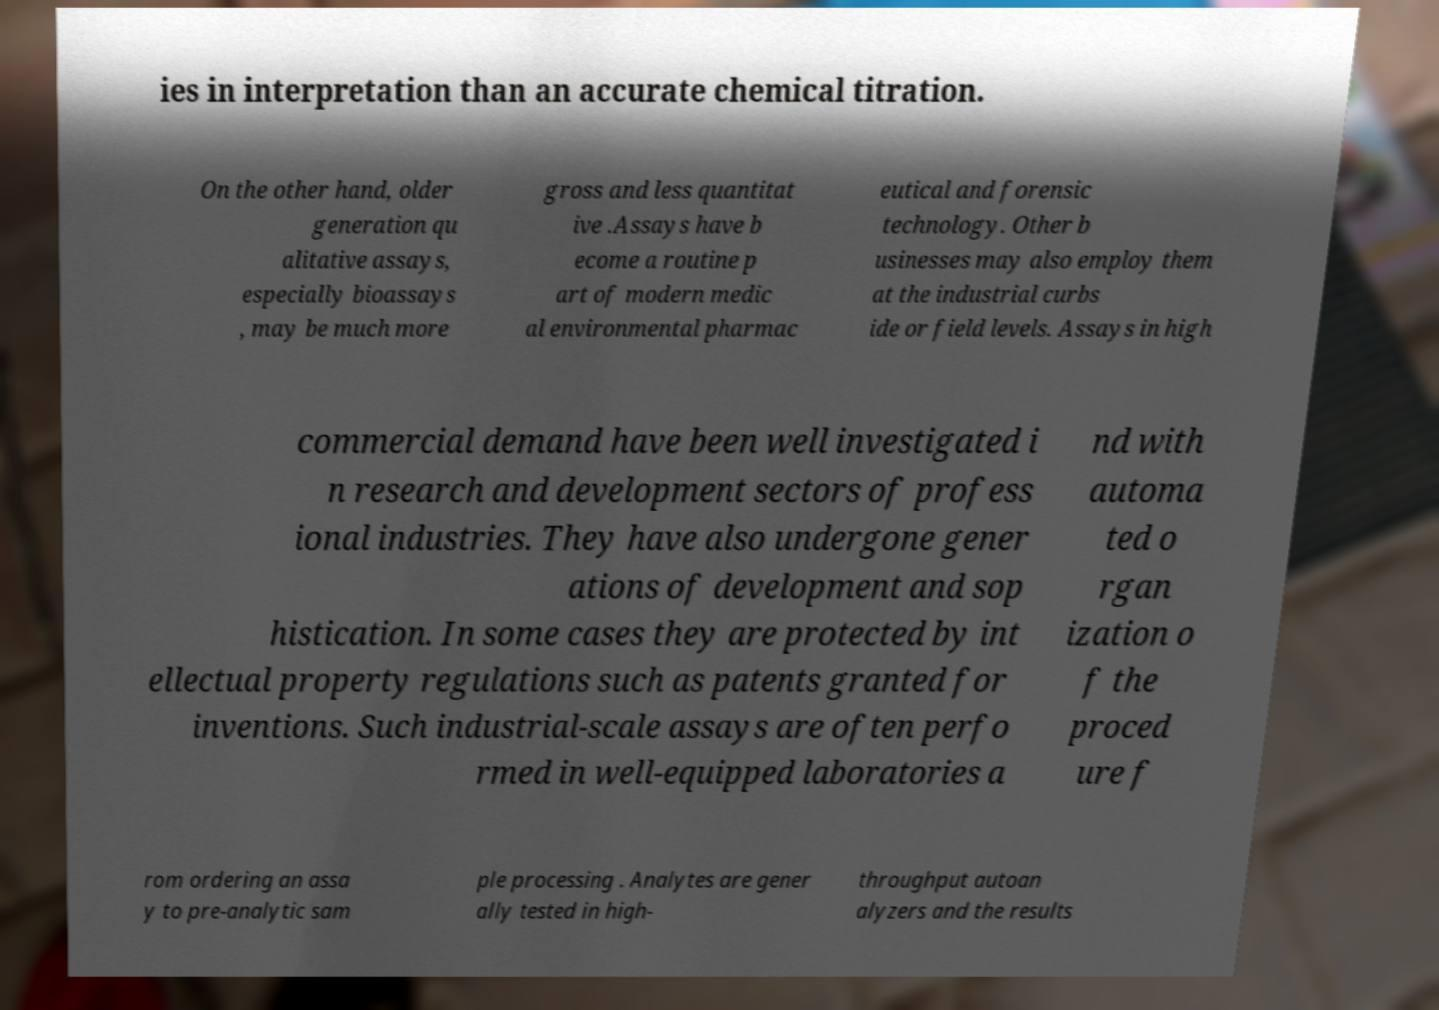What messages or text are displayed in this image? I need them in a readable, typed format. ies in interpretation than an accurate chemical titration. On the other hand, older generation qu alitative assays, especially bioassays , may be much more gross and less quantitat ive .Assays have b ecome a routine p art of modern medic al environmental pharmac eutical and forensic technology. Other b usinesses may also employ them at the industrial curbs ide or field levels. Assays in high commercial demand have been well investigated i n research and development sectors of profess ional industries. They have also undergone gener ations of development and sop histication. In some cases they are protected by int ellectual property regulations such as patents granted for inventions. Such industrial-scale assays are often perfo rmed in well-equipped laboratories a nd with automa ted o rgan ization o f the proced ure f rom ordering an assa y to pre-analytic sam ple processing . Analytes are gener ally tested in high- throughput autoan alyzers and the results 